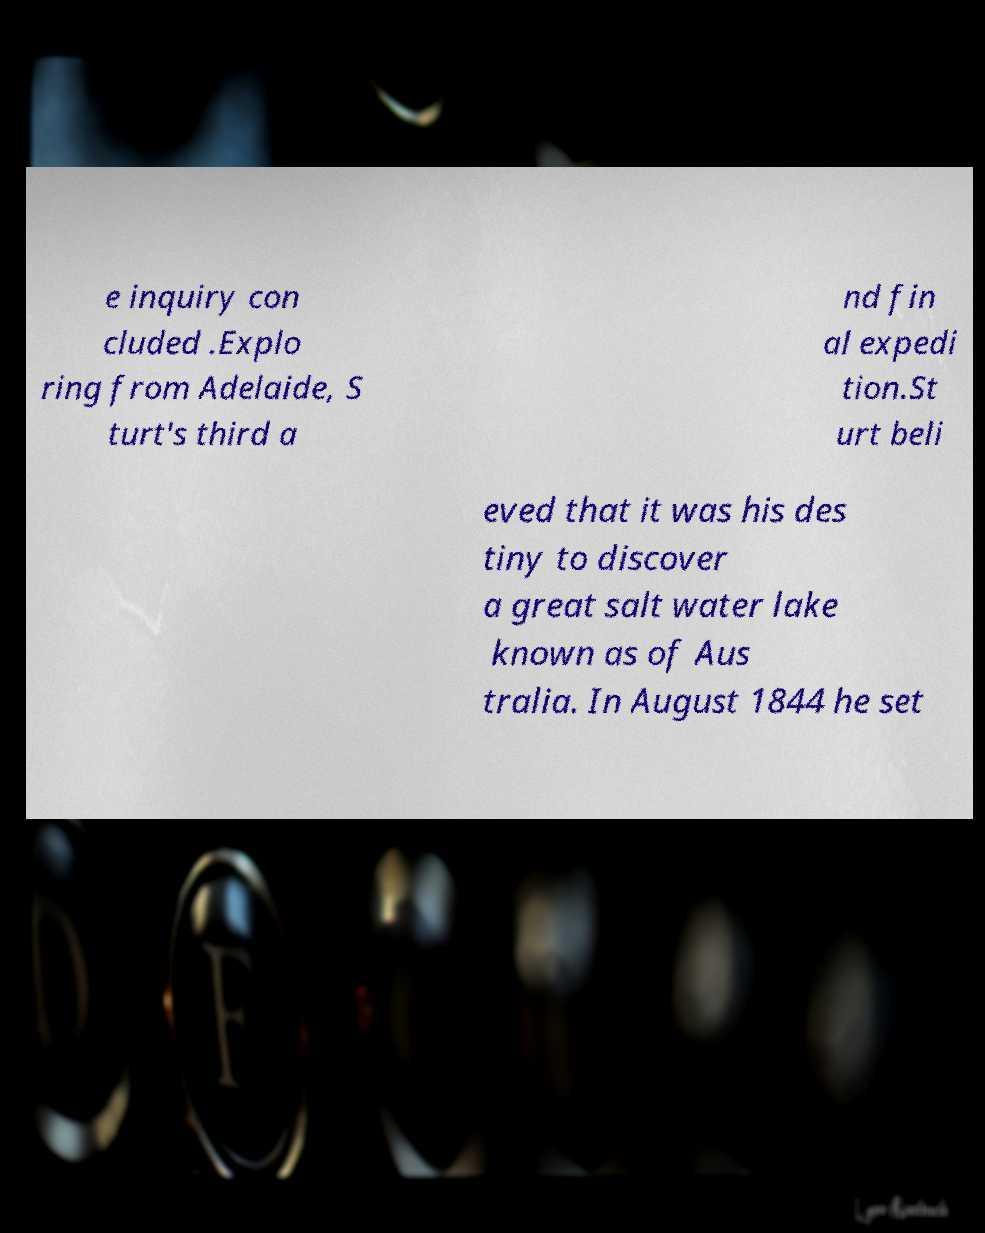There's text embedded in this image that I need extracted. Can you transcribe it verbatim? e inquiry con cluded .Explo ring from Adelaide, S turt's third a nd fin al expedi tion.St urt beli eved that it was his des tiny to discover a great salt water lake known as of Aus tralia. In August 1844 he set 